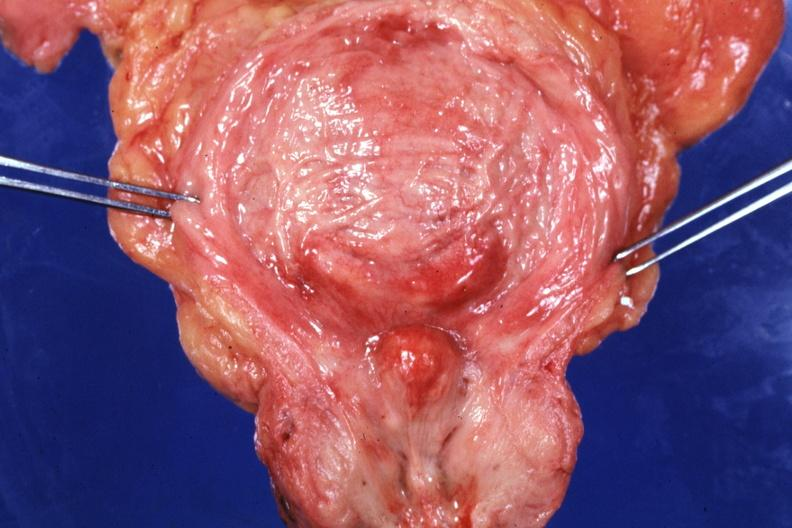what is opened bladder with median lobe protruding into trigone area also had?
Answer the question using a single word or phrase. Increase trabeculations very good slide 